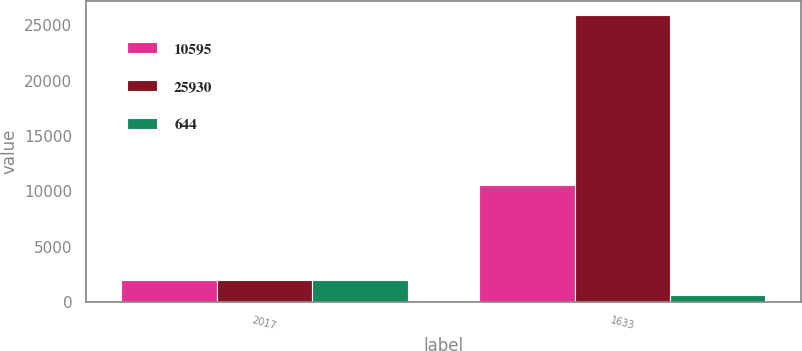Convert chart. <chart><loc_0><loc_0><loc_500><loc_500><stacked_bar_chart><ecel><fcel>2017<fcel>1633<nl><fcel>10595<fcel>2016<fcel>10595<nl><fcel>25930<fcel>2015<fcel>25930<nl><fcel>644<fcel>2014<fcel>644<nl></chart> 